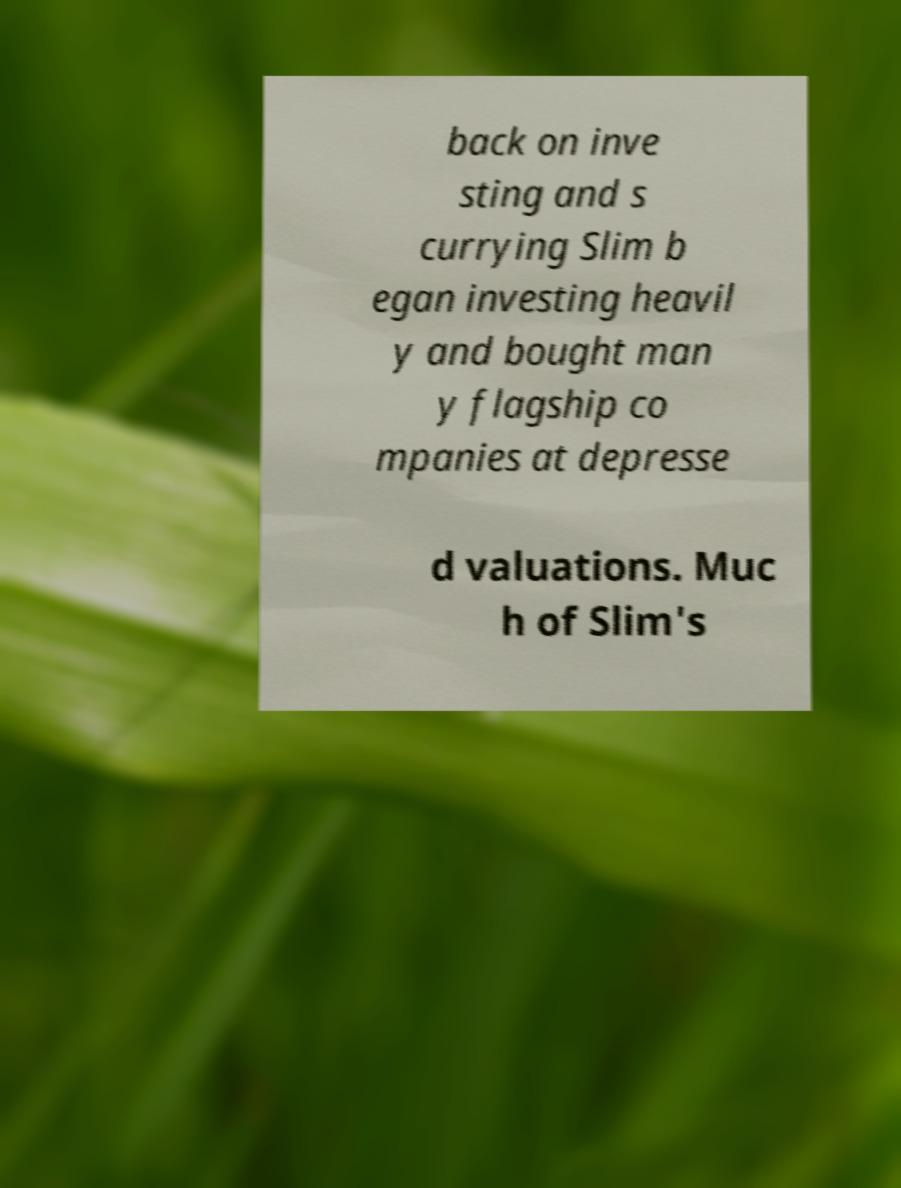What messages or text are displayed in this image? I need them in a readable, typed format. back on inve sting and s currying Slim b egan investing heavil y and bought man y flagship co mpanies at depresse d valuations. Muc h of Slim's 